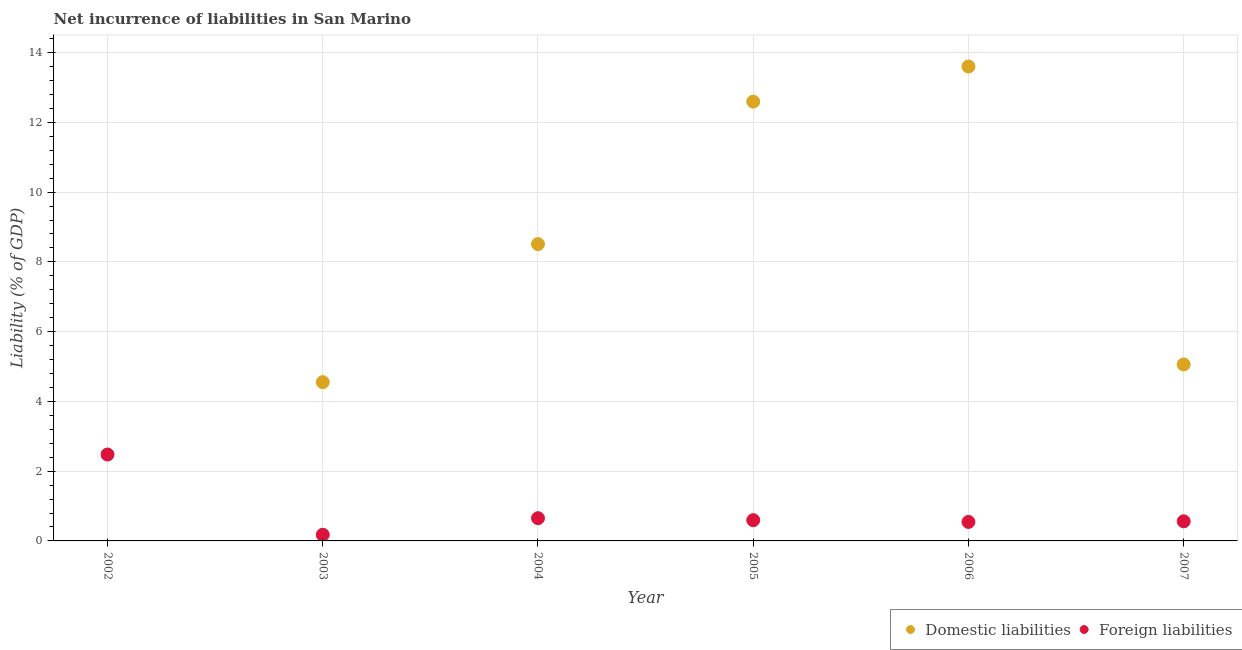How many different coloured dotlines are there?
Offer a very short reply. 2. What is the incurrence of domestic liabilities in 2006?
Provide a short and direct response. 13.6. Across all years, what is the maximum incurrence of domestic liabilities?
Provide a short and direct response. 13.6. Across all years, what is the minimum incurrence of foreign liabilities?
Provide a succinct answer. 0.18. What is the total incurrence of domestic liabilities in the graph?
Provide a short and direct response. 44.32. What is the difference between the incurrence of foreign liabilities in 2006 and that in 2007?
Your answer should be very brief. -0.02. What is the difference between the incurrence of domestic liabilities in 2007 and the incurrence of foreign liabilities in 2004?
Provide a succinct answer. 4.41. What is the average incurrence of foreign liabilities per year?
Provide a short and direct response. 0.83. In the year 2007, what is the difference between the incurrence of foreign liabilities and incurrence of domestic liabilities?
Your answer should be very brief. -4.5. What is the ratio of the incurrence of domestic liabilities in 2005 to that in 2007?
Offer a terse response. 2.49. What is the difference between the highest and the second highest incurrence of foreign liabilities?
Offer a very short reply. 1.83. What is the difference between the highest and the lowest incurrence of domestic liabilities?
Offer a very short reply. 13.6. Does the graph contain any zero values?
Your answer should be compact. Yes. Where does the legend appear in the graph?
Your response must be concise. Bottom right. How are the legend labels stacked?
Provide a short and direct response. Horizontal. What is the title of the graph?
Offer a terse response. Net incurrence of liabilities in San Marino. Does "Start a business" appear as one of the legend labels in the graph?
Provide a succinct answer. No. What is the label or title of the X-axis?
Offer a very short reply. Year. What is the label or title of the Y-axis?
Your response must be concise. Liability (% of GDP). What is the Liability (% of GDP) in Domestic liabilities in 2002?
Provide a short and direct response. 0. What is the Liability (% of GDP) in Foreign liabilities in 2002?
Provide a succinct answer. 2.48. What is the Liability (% of GDP) of Domestic liabilities in 2003?
Make the answer very short. 4.55. What is the Liability (% of GDP) of Foreign liabilities in 2003?
Keep it short and to the point. 0.18. What is the Liability (% of GDP) of Domestic liabilities in 2004?
Keep it short and to the point. 8.51. What is the Liability (% of GDP) of Foreign liabilities in 2004?
Offer a terse response. 0.65. What is the Liability (% of GDP) in Domestic liabilities in 2005?
Ensure brevity in your answer.  12.59. What is the Liability (% of GDP) of Foreign liabilities in 2005?
Your answer should be very brief. 0.59. What is the Liability (% of GDP) in Domestic liabilities in 2006?
Make the answer very short. 13.6. What is the Liability (% of GDP) in Foreign liabilities in 2006?
Keep it short and to the point. 0.54. What is the Liability (% of GDP) of Domestic liabilities in 2007?
Give a very brief answer. 5.06. What is the Liability (% of GDP) in Foreign liabilities in 2007?
Provide a succinct answer. 0.56. Across all years, what is the maximum Liability (% of GDP) of Domestic liabilities?
Keep it short and to the point. 13.6. Across all years, what is the maximum Liability (% of GDP) in Foreign liabilities?
Give a very brief answer. 2.48. Across all years, what is the minimum Liability (% of GDP) in Foreign liabilities?
Your answer should be very brief. 0.18. What is the total Liability (% of GDP) in Domestic liabilities in the graph?
Keep it short and to the point. 44.32. What is the total Liability (% of GDP) of Foreign liabilities in the graph?
Your answer should be very brief. 5.01. What is the difference between the Liability (% of GDP) in Foreign liabilities in 2002 and that in 2003?
Your answer should be very brief. 2.3. What is the difference between the Liability (% of GDP) of Foreign liabilities in 2002 and that in 2004?
Ensure brevity in your answer.  1.83. What is the difference between the Liability (% of GDP) of Foreign liabilities in 2002 and that in 2005?
Ensure brevity in your answer.  1.88. What is the difference between the Liability (% of GDP) in Foreign liabilities in 2002 and that in 2006?
Offer a very short reply. 1.93. What is the difference between the Liability (% of GDP) of Foreign liabilities in 2002 and that in 2007?
Provide a short and direct response. 1.92. What is the difference between the Liability (% of GDP) in Domestic liabilities in 2003 and that in 2004?
Your answer should be very brief. -3.96. What is the difference between the Liability (% of GDP) of Foreign liabilities in 2003 and that in 2004?
Your answer should be very brief. -0.48. What is the difference between the Liability (% of GDP) of Domestic liabilities in 2003 and that in 2005?
Keep it short and to the point. -8.04. What is the difference between the Liability (% of GDP) of Foreign liabilities in 2003 and that in 2005?
Provide a short and direct response. -0.42. What is the difference between the Liability (% of GDP) in Domestic liabilities in 2003 and that in 2006?
Your answer should be very brief. -9.05. What is the difference between the Liability (% of GDP) in Foreign liabilities in 2003 and that in 2006?
Keep it short and to the point. -0.37. What is the difference between the Liability (% of GDP) in Domestic liabilities in 2003 and that in 2007?
Offer a very short reply. -0.51. What is the difference between the Liability (% of GDP) in Foreign liabilities in 2003 and that in 2007?
Provide a short and direct response. -0.39. What is the difference between the Liability (% of GDP) of Domestic liabilities in 2004 and that in 2005?
Your answer should be very brief. -4.08. What is the difference between the Liability (% of GDP) of Foreign liabilities in 2004 and that in 2005?
Your answer should be compact. 0.06. What is the difference between the Liability (% of GDP) in Domestic liabilities in 2004 and that in 2006?
Make the answer very short. -5.09. What is the difference between the Liability (% of GDP) in Foreign liabilities in 2004 and that in 2006?
Provide a succinct answer. 0.11. What is the difference between the Liability (% of GDP) in Domestic liabilities in 2004 and that in 2007?
Keep it short and to the point. 3.45. What is the difference between the Liability (% of GDP) of Foreign liabilities in 2004 and that in 2007?
Keep it short and to the point. 0.09. What is the difference between the Liability (% of GDP) of Domestic liabilities in 2005 and that in 2006?
Offer a terse response. -1.01. What is the difference between the Liability (% of GDP) of Foreign liabilities in 2005 and that in 2006?
Make the answer very short. 0.05. What is the difference between the Liability (% of GDP) of Domestic liabilities in 2005 and that in 2007?
Your answer should be very brief. 7.54. What is the difference between the Liability (% of GDP) of Foreign liabilities in 2005 and that in 2007?
Your response must be concise. 0.03. What is the difference between the Liability (% of GDP) in Domestic liabilities in 2006 and that in 2007?
Give a very brief answer. 8.54. What is the difference between the Liability (% of GDP) of Foreign liabilities in 2006 and that in 2007?
Your answer should be very brief. -0.02. What is the difference between the Liability (% of GDP) in Domestic liabilities in 2003 and the Liability (% of GDP) in Foreign liabilities in 2004?
Keep it short and to the point. 3.9. What is the difference between the Liability (% of GDP) in Domestic liabilities in 2003 and the Liability (% of GDP) in Foreign liabilities in 2005?
Keep it short and to the point. 3.96. What is the difference between the Liability (% of GDP) of Domestic liabilities in 2003 and the Liability (% of GDP) of Foreign liabilities in 2006?
Your response must be concise. 4.01. What is the difference between the Liability (% of GDP) of Domestic liabilities in 2003 and the Liability (% of GDP) of Foreign liabilities in 2007?
Give a very brief answer. 3.99. What is the difference between the Liability (% of GDP) of Domestic liabilities in 2004 and the Liability (% of GDP) of Foreign liabilities in 2005?
Keep it short and to the point. 7.92. What is the difference between the Liability (% of GDP) of Domestic liabilities in 2004 and the Liability (% of GDP) of Foreign liabilities in 2006?
Give a very brief answer. 7.97. What is the difference between the Liability (% of GDP) in Domestic liabilities in 2004 and the Liability (% of GDP) in Foreign liabilities in 2007?
Provide a succinct answer. 7.95. What is the difference between the Liability (% of GDP) of Domestic liabilities in 2005 and the Liability (% of GDP) of Foreign liabilities in 2006?
Ensure brevity in your answer.  12.05. What is the difference between the Liability (% of GDP) in Domestic liabilities in 2005 and the Liability (% of GDP) in Foreign liabilities in 2007?
Keep it short and to the point. 12.03. What is the difference between the Liability (% of GDP) in Domestic liabilities in 2006 and the Liability (% of GDP) in Foreign liabilities in 2007?
Give a very brief answer. 13.04. What is the average Liability (% of GDP) in Domestic liabilities per year?
Offer a terse response. 7.39. What is the average Liability (% of GDP) in Foreign liabilities per year?
Offer a very short reply. 0.83. In the year 2003, what is the difference between the Liability (% of GDP) in Domestic liabilities and Liability (% of GDP) in Foreign liabilities?
Your answer should be very brief. 4.38. In the year 2004, what is the difference between the Liability (% of GDP) of Domestic liabilities and Liability (% of GDP) of Foreign liabilities?
Provide a succinct answer. 7.86. In the year 2005, what is the difference between the Liability (% of GDP) in Domestic liabilities and Liability (% of GDP) in Foreign liabilities?
Your answer should be compact. 12. In the year 2006, what is the difference between the Liability (% of GDP) in Domestic liabilities and Liability (% of GDP) in Foreign liabilities?
Keep it short and to the point. 13.06. In the year 2007, what is the difference between the Liability (% of GDP) in Domestic liabilities and Liability (% of GDP) in Foreign liabilities?
Keep it short and to the point. 4.5. What is the ratio of the Liability (% of GDP) in Foreign liabilities in 2002 to that in 2003?
Your answer should be very brief. 14.03. What is the ratio of the Liability (% of GDP) in Foreign liabilities in 2002 to that in 2004?
Your response must be concise. 3.8. What is the ratio of the Liability (% of GDP) in Foreign liabilities in 2002 to that in 2005?
Your answer should be very brief. 4.17. What is the ratio of the Liability (% of GDP) in Foreign liabilities in 2002 to that in 2006?
Make the answer very short. 4.55. What is the ratio of the Liability (% of GDP) of Foreign liabilities in 2002 to that in 2007?
Offer a terse response. 4.41. What is the ratio of the Liability (% of GDP) in Domestic liabilities in 2003 to that in 2004?
Offer a very short reply. 0.53. What is the ratio of the Liability (% of GDP) of Foreign liabilities in 2003 to that in 2004?
Your response must be concise. 0.27. What is the ratio of the Liability (% of GDP) in Domestic liabilities in 2003 to that in 2005?
Give a very brief answer. 0.36. What is the ratio of the Liability (% of GDP) of Foreign liabilities in 2003 to that in 2005?
Make the answer very short. 0.3. What is the ratio of the Liability (% of GDP) in Domestic liabilities in 2003 to that in 2006?
Offer a terse response. 0.33. What is the ratio of the Liability (% of GDP) of Foreign liabilities in 2003 to that in 2006?
Make the answer very short. 0.32. What is the ratio of the Liability (% of GDP) in Domestic liabilities in 2003 to that in 2007?
Your answer should be very brief. 0.9. What is the ratio of the Liability (% of GDP) in Foreign liabilities in 2003 to that in 2007?
Your answer should be very brief. 0.31. What is the ratio of the Liability (% of GDP) of Domestic liabilities in 2004 to that in 2005?
Keep it short and to the point. 0.68. What is the ratio of the Liability (% of GDP) of Foreign liabilities in 2004 to that in 2005?
Make the answer very short. 1.1. What is the ratio of the Liability (% of GDP) of Domestic liabilities in 2004 to that in 2006?
Provide a succinct answer. 0.63. What is the ratio of the Liability (% of GDP) in Foreign liabilities in 2004 to that in 2006?
Make the answer very short. 1.2. What is the ratio of the Liability (% of GDP) of Domestic liabilities in 2004 to that in 2007?
Provide a short and direct response. 1.68. What is the ratio of the Liability (% of GDP) in Foreign liabilities in 2004 to that in 2007?
Provide a succinct answer. 1.16. What is the ratio of the Liability (% of GDP) of Domestic liabilities in 2005 to that in 2006?
Ensure brevity in your answer.  0.93. What is the ratio of the Liability (% of GDP) of Foreign liabilities in 2005 to that in 2006?
Offer a very short reply. 1.09. What is the ratio of the Liability (% of GDP) in Domestic liabilities in 2005 to that in 2007?
Your answer should be compact. 2.49. What is the ratio of the Liability (% of GDP) in Foreign liabilities in 2005 to that in 2007?
Provide a succinct answer. 1.06. What is the ratio of the Liability (% of GDP) of Domestic liabilities in 2006 to that in 2007?
Your response must be concise. 2.69. What is the ratio of the Liability (% of GDP) of Foreign liabilities in 2006 to that in 2007?
Provide a succinct answer. 0.97. What is the difference between the highest and the second highest Liability (% of GDP) of Domestic liabilities?
Provide a short and direct response. 1.01. What is the difference between the highest and the second highest Liability (% of GDP) of Foreign liabilities?
Ensure brevity in your answer.  1.83. What is the difference between the highest and the lowest Liability (% of GDP) in Domestic liabilities?
Your answer should be compact. 13.6. What is the difference between the highest and the lowest Liability (% of GDP) of Foreign liabilities?
Make the answer very short. 2.3. 